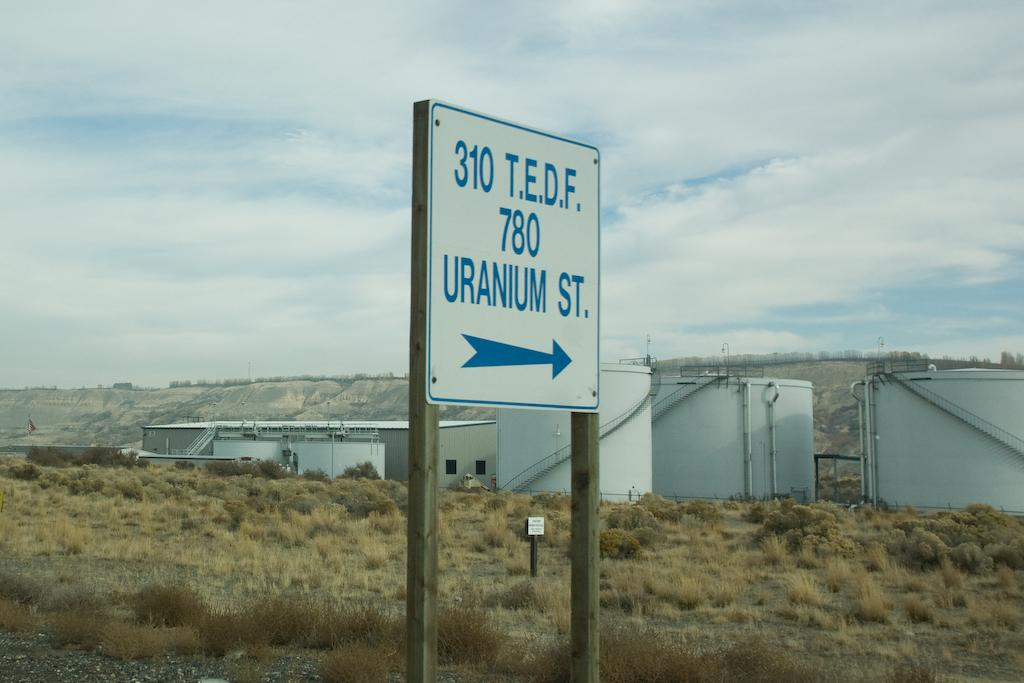<image>
Render a clear and concise summary of the photo. the number 310 is on the sign outside 